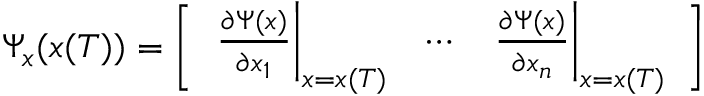<formula> <loc_0><loc_0><loc_500><loc_500>\Psi _ { x } ( x ( T ) ) = { \left [ \begin{array} { l l l } { { \frac { \partial \Psi ( x ) } { \partial x _ { 1 } } } \right | _ { x = x ( T ) } } & { \cdots } & { { \frac { \partial \Psi ( x ) } { \partial x _ { n } } } \right | _ { x = x ( T ) } } \end{array} \right ] }</formula> 